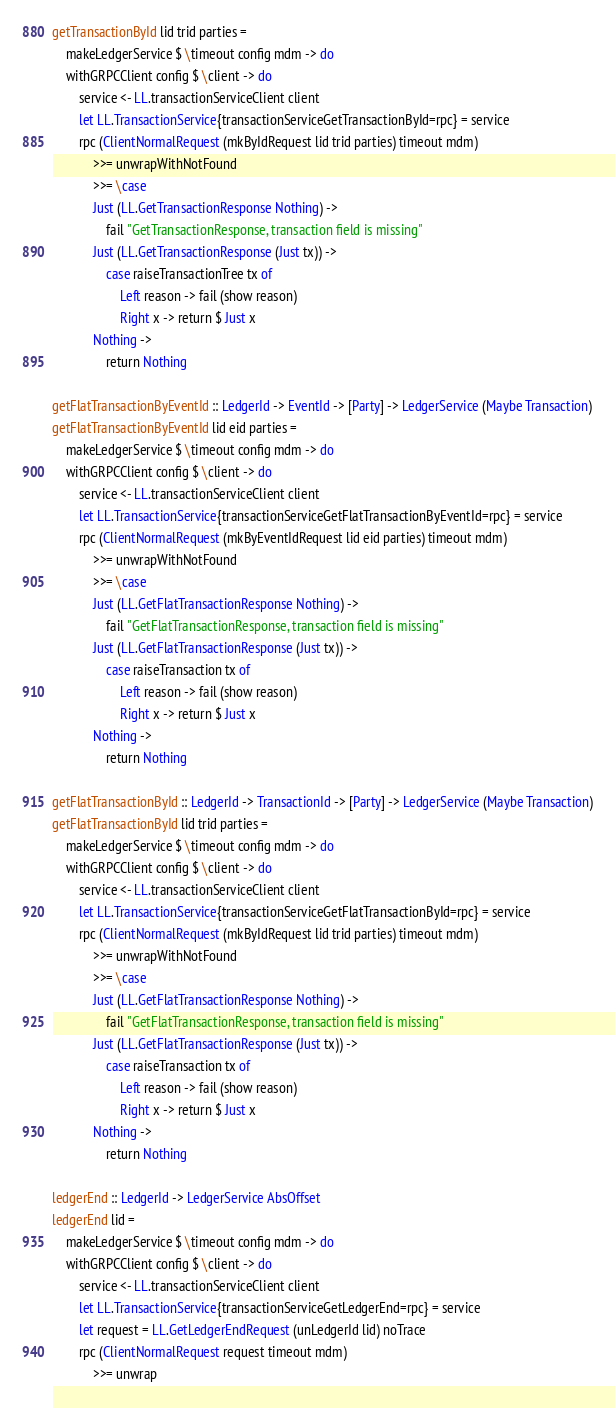<code> <loc_0><loc_0><loc_500><loc_500><_Haskell_>getTransactionById lid trid parties =
    makeLedgerService $ \timeout config mdm -> do
    withGRPCClient config $ \client -> do
        service <- LL.transactionServiceClient client
        let LL.TransactionService{transactionServiceGetTransactionById=rpc} = service
        rpc (ClientNormalRequest (mkByIdRequest lid trid parties) timeout mdm)
            >>= unwrapWithNotFound
            >>= \case
            Just (LL.GetTransactionResponse Nothing) ->
                fail "GetTransactionResponse, transaction field is missing"
            Just (LL.GetTransactionResponse (Just tx)) ->
                case raiseTransactionTree tx of
                    Left reason -> fail (show reason)
                    Right x -> return $ Just x
            Nothing ->
                return Nothing

getFlatTransactionByEventId :: LedgerId -> EventId -> [Party] -> LedgerService (Maybe Transaction)
getFlatTransactionByEventId lid eid parties =
    makeLedgerService $ \timeout config mdm -> do
    withGRPCClient config $ \client -> do
        service <- LL.transactionServiceClient client
        let LL.TransactionService{transactionServiceGetFlatTransactionByEventId=rpc} = service
        rpc (ClientNormalRequest (mkByEventIdRequest lid eid parties) timeout mdm)
            >>= unwrapWithNotFound
            >>= \case
            Just (LL.GetFlatTransactionResponse Nothing) ->
                fail "GetFlatTransactionResponse, transaction field is missing"
            Just (LL.GetFlatTransactionResponse (Just tx)) ->
                case raiseTransaction tx of
                    Left reason -> fail (show reason)
                    Right x -> return $ Just x
            Nothing ->
                return Nothing

getFlatTransactionById :: LedgerId -> TransactionId -> [Party] -> LedgerService (Maybe Transaction)
getFlatTransactionById lid trid parties =
    makeLedgerService $ \timeout config mdm -> do
    withGRPCClient config $ \client -> do
        service <- LL.transactionServiceClient client
        let LL.TransactionService{transactionServiceGetFlatTransactionById=rpc} = service
        rpc (ClientNormalRequest (mkByIdRequest lid trid parties) timeout mdm)
            >>= unwrapWithNotFound
            >>= \case
            Just (LL.GetFlatTransactionResponse Nothing) ->
                fail "GetFlatTransactionResponse, transaction field is missing"
            Just (LL.GetFlatTransactionResponse (Just tx)) ->
                case raiseTransaction tx of
                    Left reason -> fail (show reason)
                    Right x -> return $ Just x
            Nothing ->
                return Nothing

ledgerEnd :: LedgerId -> LedgerService AbsOffset
ledgerEnd lid =
    makeLedgerService $ \timeout config mdm -> do
    withGRPCClient config $ \client -> do
        service <- LL.transactionServiceClient client
        let LL.TransactionService{transactionServiceGetLedgerEnd=rpc} = service
        let request = LL.GetLedgerEndRequest (unLedgerId lid) noTrace
        rpc (ClientNormalRequest request timeout mdm)
            >>= unwrap</code> 